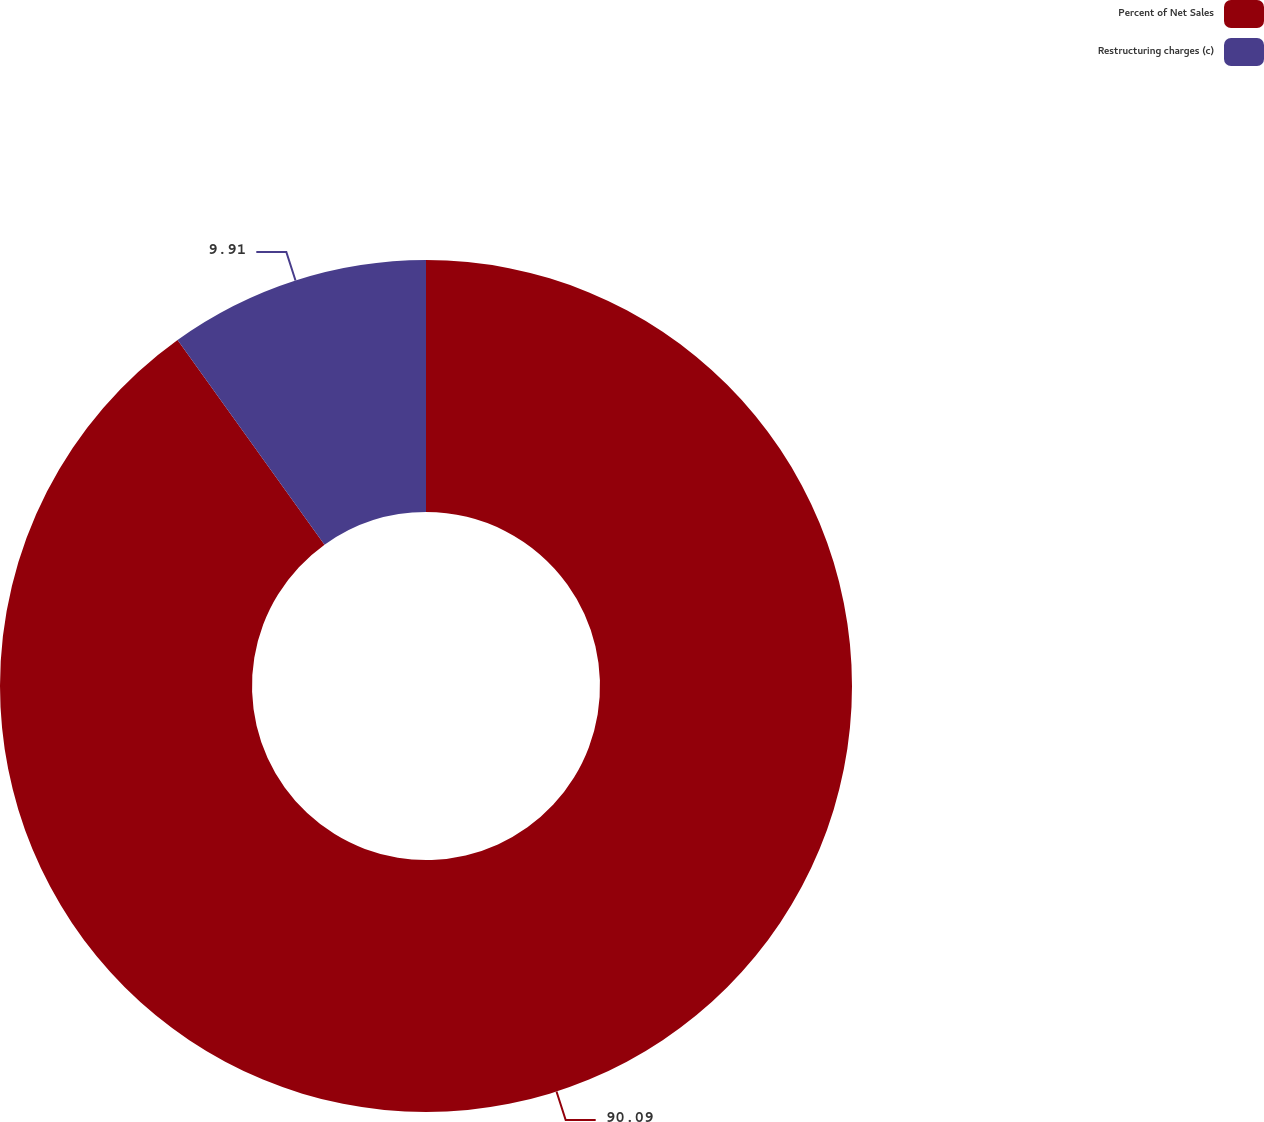Convert chart. <chart><loc_0><loc_0><loc_500><loc_500><pie_chart><fcel>Percent of Net Sales<fcel>Restructuring charges (c)<nl><fcel>90.09%<fcel>9.91%<nl></chart> 